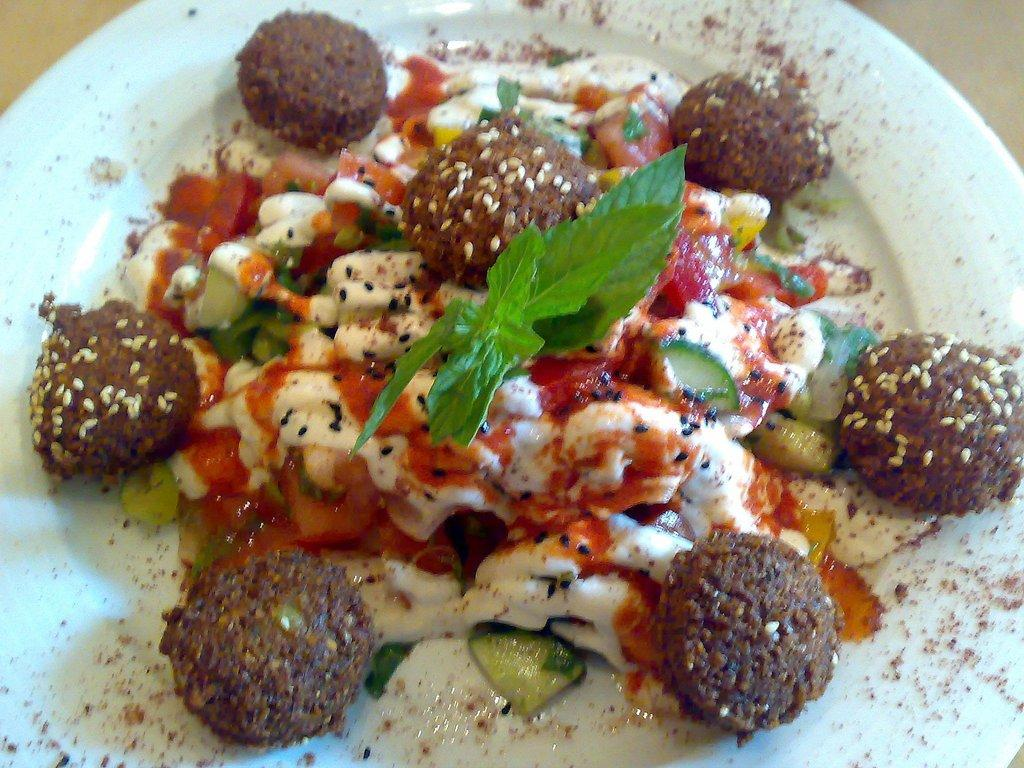What is on the plate that is visible in the image? There is food on a plate in the image. Where is the plate located in the image? The plate is in the center of the image. What is the rate of the food's decomposition in the image? There is no information about the rate of decomposition of the food in the image. 